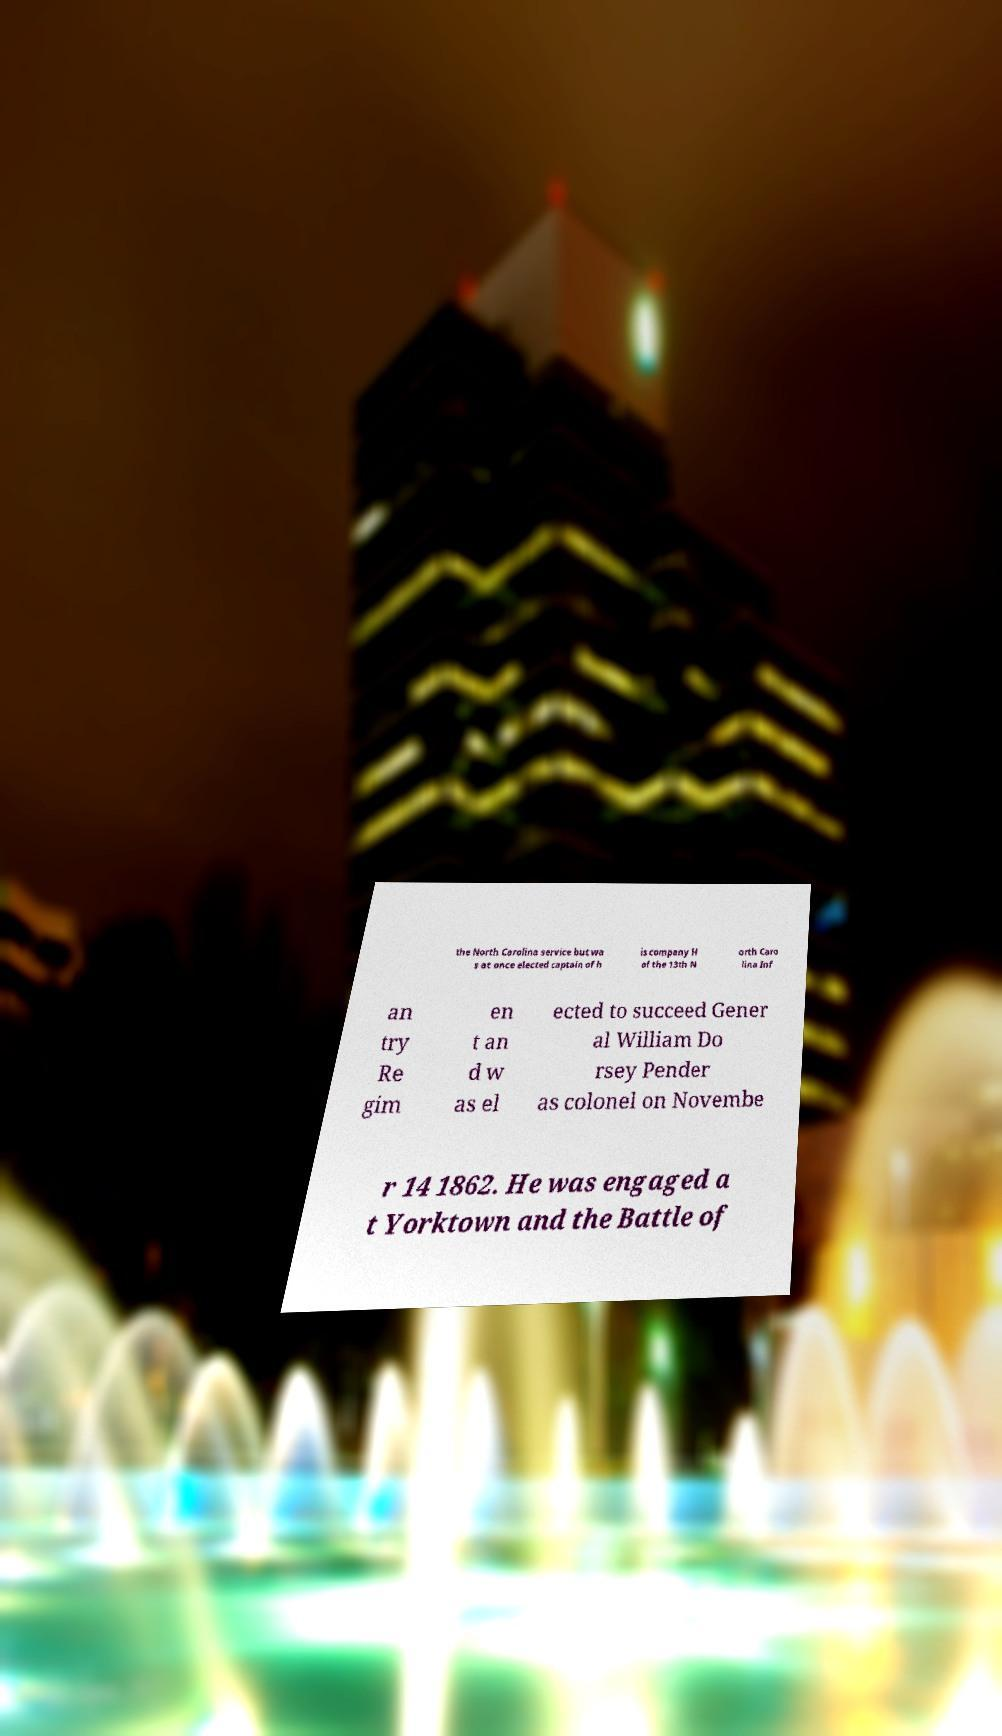Could you extract and type out the text from this image? the North Carolina service but wa s at once elected captain of h is company H of the 13th N orth Caro lina Inf an try Re gim en t an d w as el ected to succeed Gener al William Do rsey Pender as colonel on Novembe r 14 1862. He was engaged a t Yorktown and the Battle of 